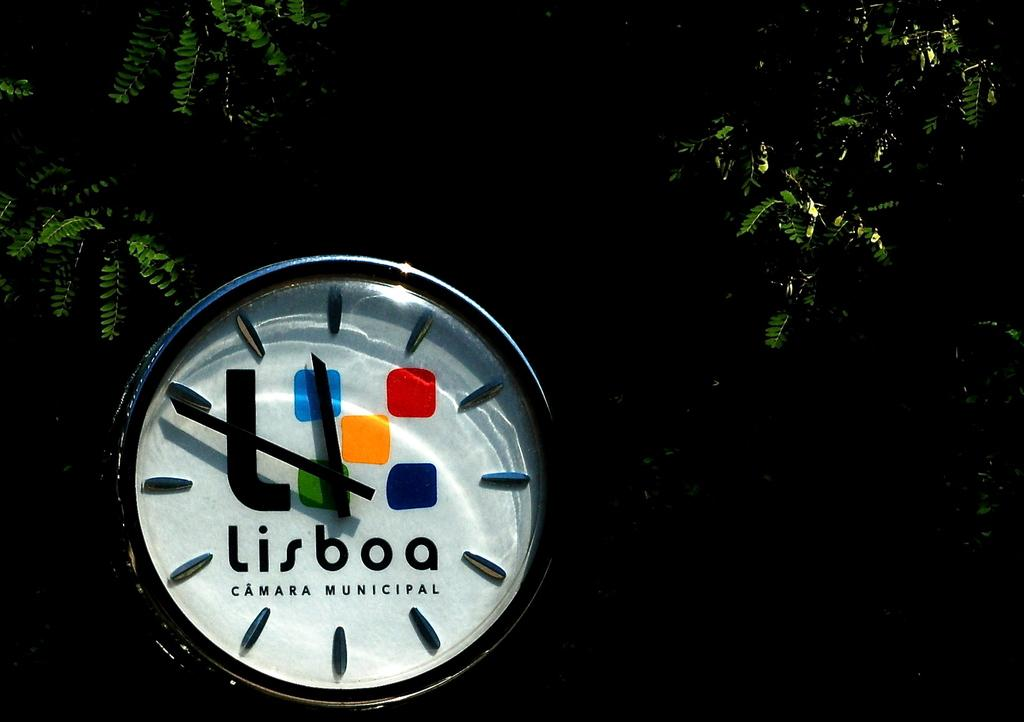<image>
Relay a brief, clear account of the picture shown. a lisboa that is on a watch with white 